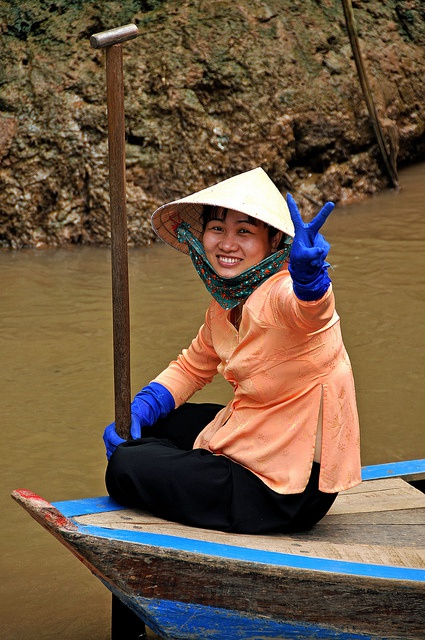Describe the objects in this image and their specific colors. I can see people in black and salmon tones and boat in black, tan, and lightblue tones in this image. 